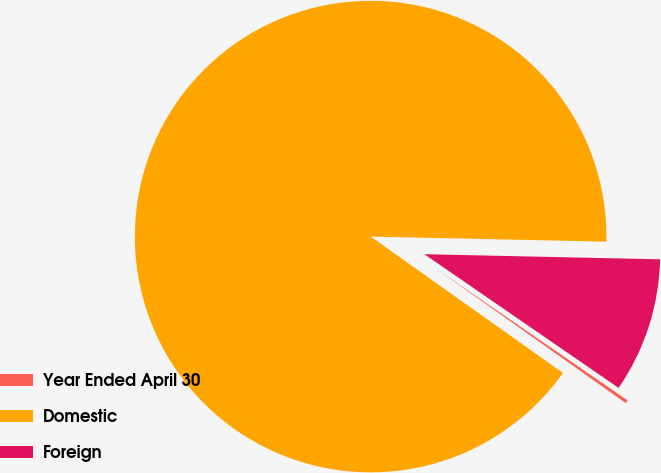Convert chart. <chart><loc_0><loc_0><loc_500><loc_500><pie_chart><fcel>Year Ended April 30<fcel>Domestic<fcel>Foreign<nl><fcel>0.22%<fcel>90.52%<fcel>9.25%<nl></chart> 